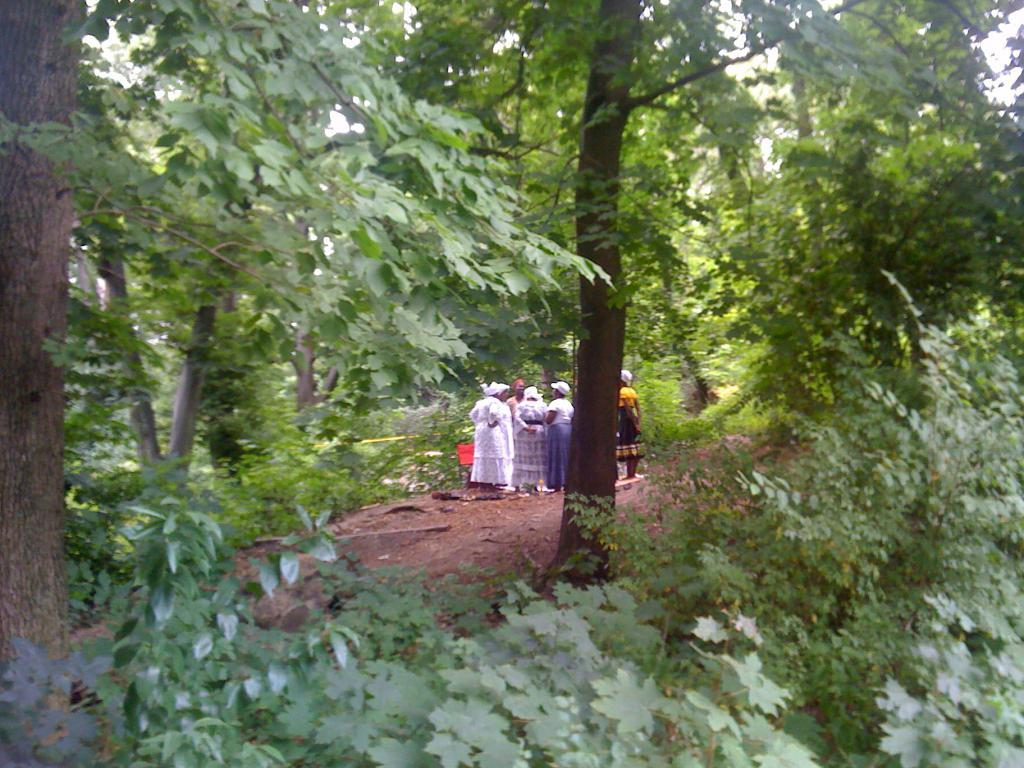What is the main subject of the image? The main subject of the image is a group of people. Where are the people located in the image? The people are standing on the ground in the center of the image. What can be seen in the background of the image? There is a group of trees and the sky visible in the background of the image. What type of frame is used to display the airport in the image? There is no airport present in the image, and therefore no frame is needed to display it. 